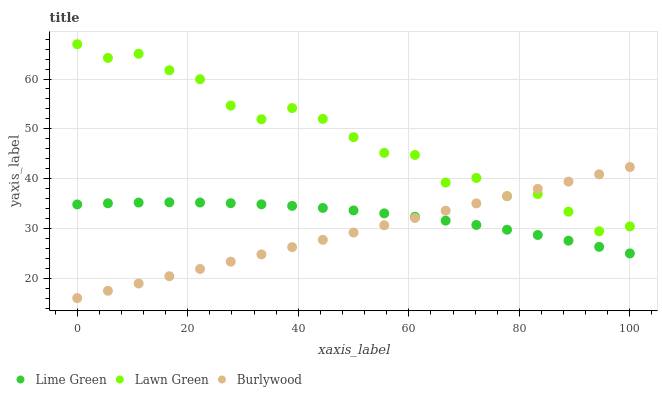Does Burlywood have the minimum area under the curve?
Answer yes or no. Yes. Does Lawn Green have the maximum area under the curve?
Answer yes or no. Yes. Does Lime Green have the minimum area under the curve?
Answer yes or no. No. Does Lime Green have the maximum area under the curve?
Answer yes or no. No. Is Burlywood the smoothest?
Answer yes or no. Yes. Is Lawn Green the roughest?
Answer yes or no. Yes. Is Lime Green the smoothest?
Answer yes or no. No. Is Lime Green the roughest?
Answer yes or no. No. Does Burlywood have the lowest value?
Answer yes or no. Yes. Does Lime Green have the lowest value?
Answer yes or no. No. Does Lawn Green have the highest value?
Answer yes or no. Yes. Does Lime Green have the highest value?
Answer yes or no. No. Is Lime Green less than Lawn Green?
Answer yes or no. Yes. Is Lawn Green greater than Lime Green?
Answer yes or no. Yes. Does Burlywood intersect Lawn Green?
Answer yes or no. Yes. Is Burlywood less than Lawn Green?
Answer yes or no. No. Is Burlywood greater than Lawn Green?
Answer yes or no. No. Does Lime Green intersect Lawn Green?
Answer yes or no. No. 